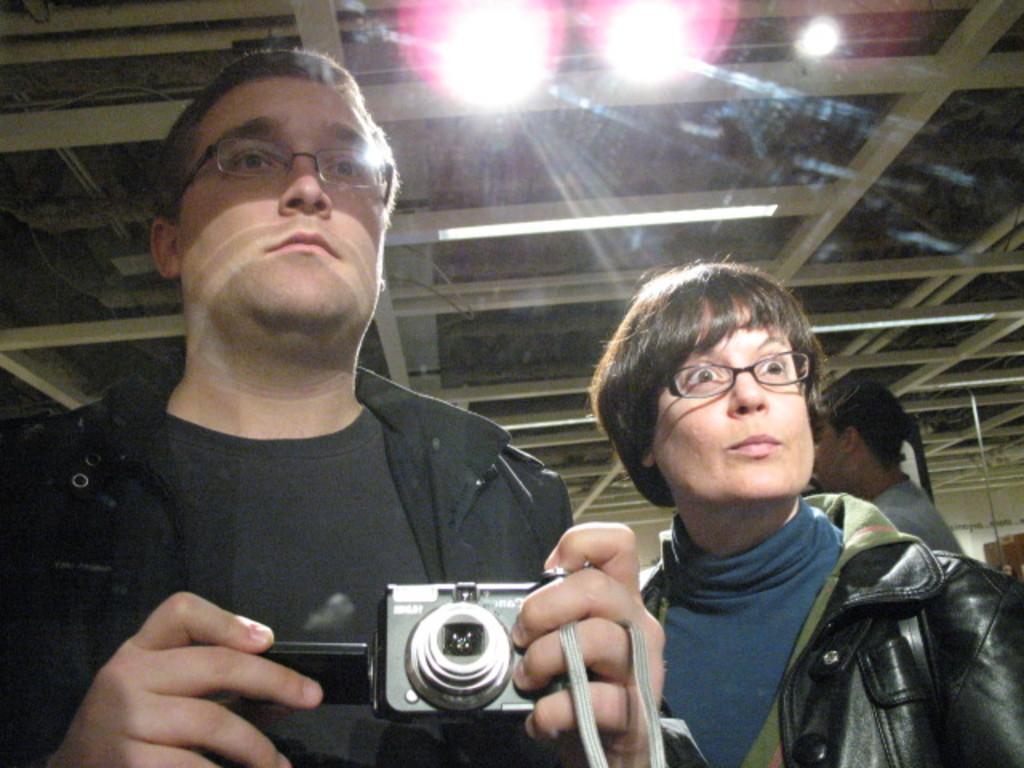Describe this image in one or two sentences. The person wearing a black dress is holding a camera in his hand and the lady beside him is standing. 